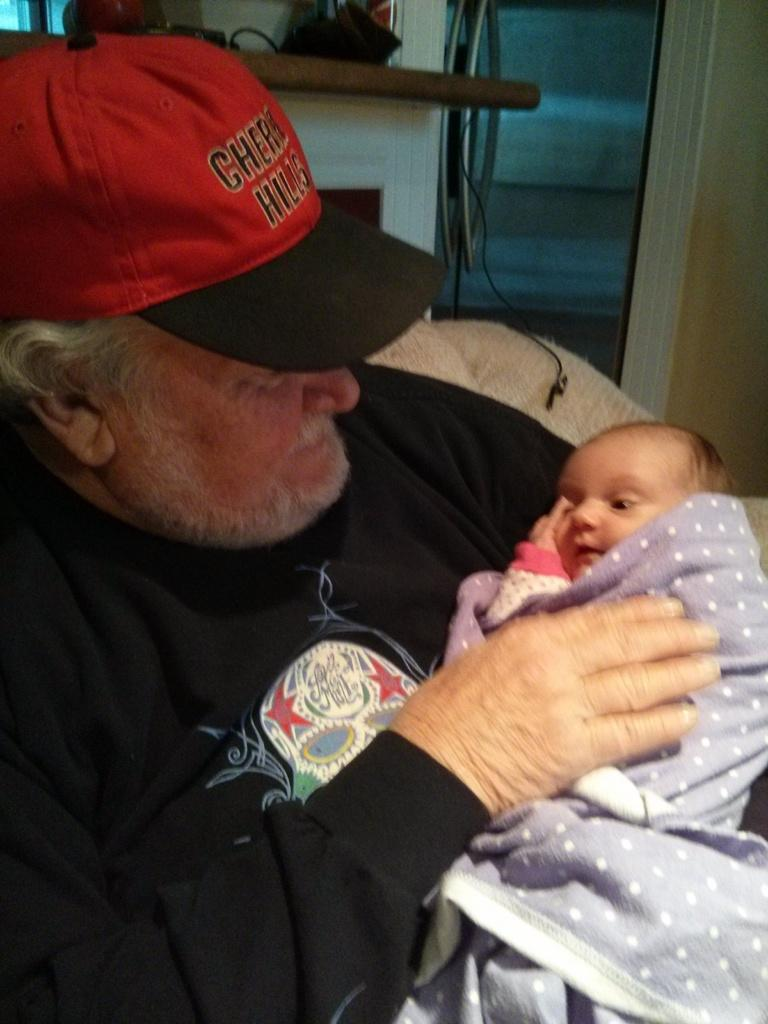Provide a one-sentence caption for the provided image. Cherry Hills is embroidered onto this gentleman's hat. 